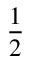Convert formula to latex. <formula><loc_0><loc_0><loc_500><loc_500>\frac { 1 } { 2 }</formula> 